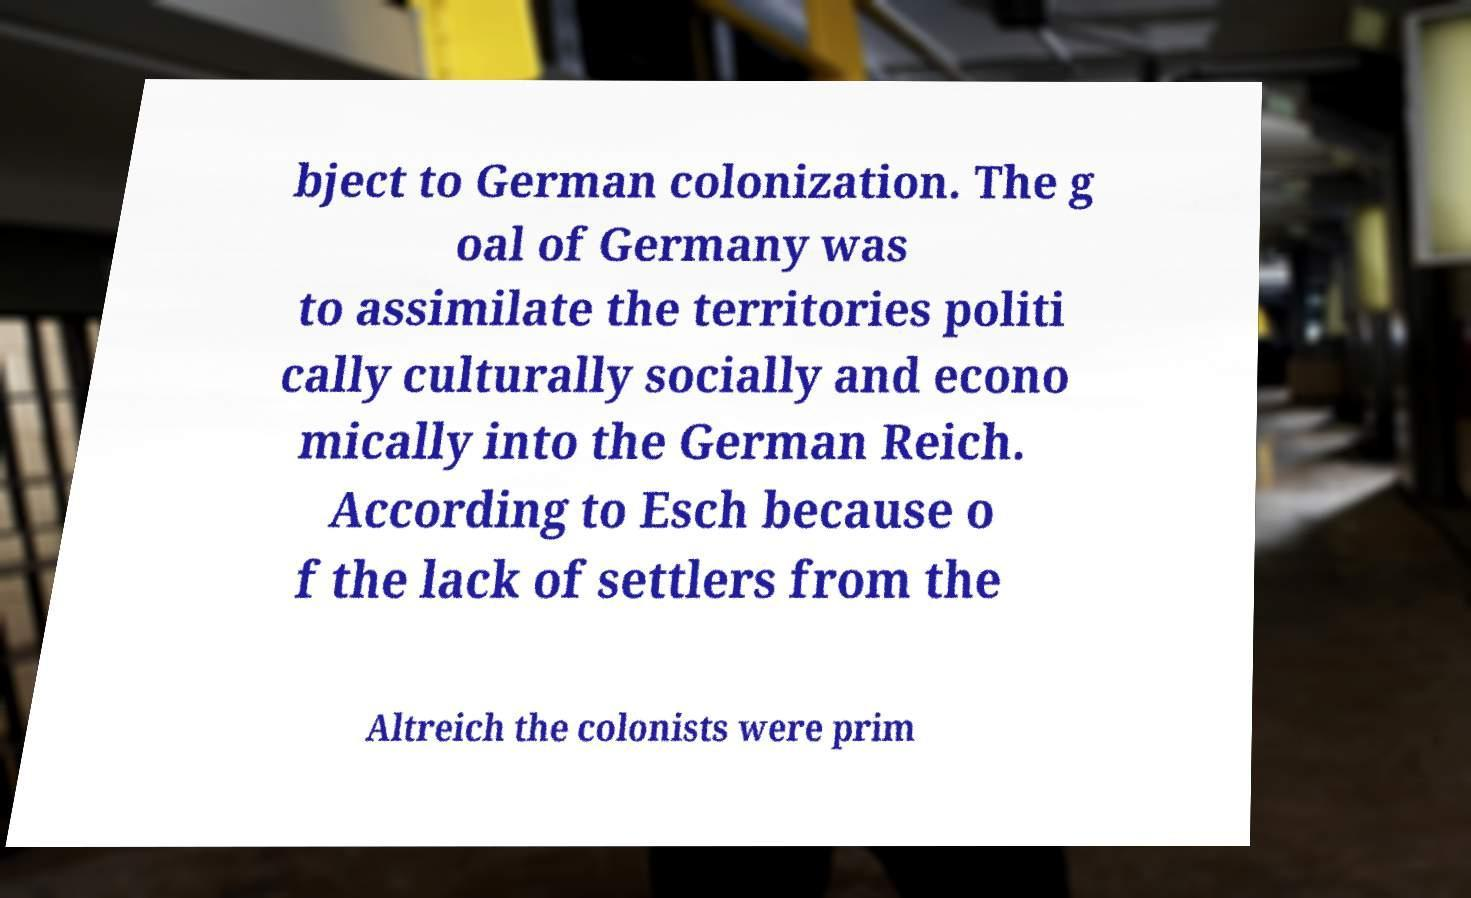Can you read and provide the text displayed in the image?This photo seems to have some interesting text. Can you extract and type it out for me? bject to German colonization. The g oal of Germany was to assimilate the territories politi cally culturally socially and econo mically into the German Reich. According to Esch because o f the lack of settlers from the Altreich the colonists were prim 